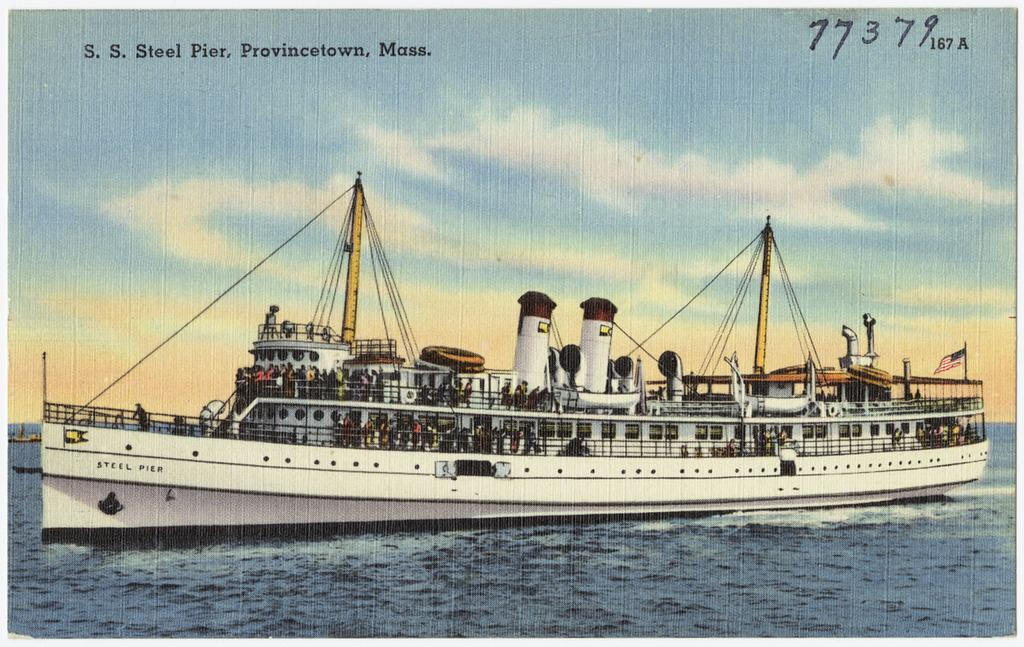What is the main subject of the image? The main subject of the image is a ship. What features can be seen on the ship? The ship has poles and cables, as well as a flag. What is the ship doing in the image? The ship is sailing on the water. What is the condition of the sky in the background? The sky in the background is cloudy. How many chickens are on the ship in the image? There are no chickens present on the ship in the image. Who is the expert on the ship in the image? There is no expert mentioned or depicted in the image. 